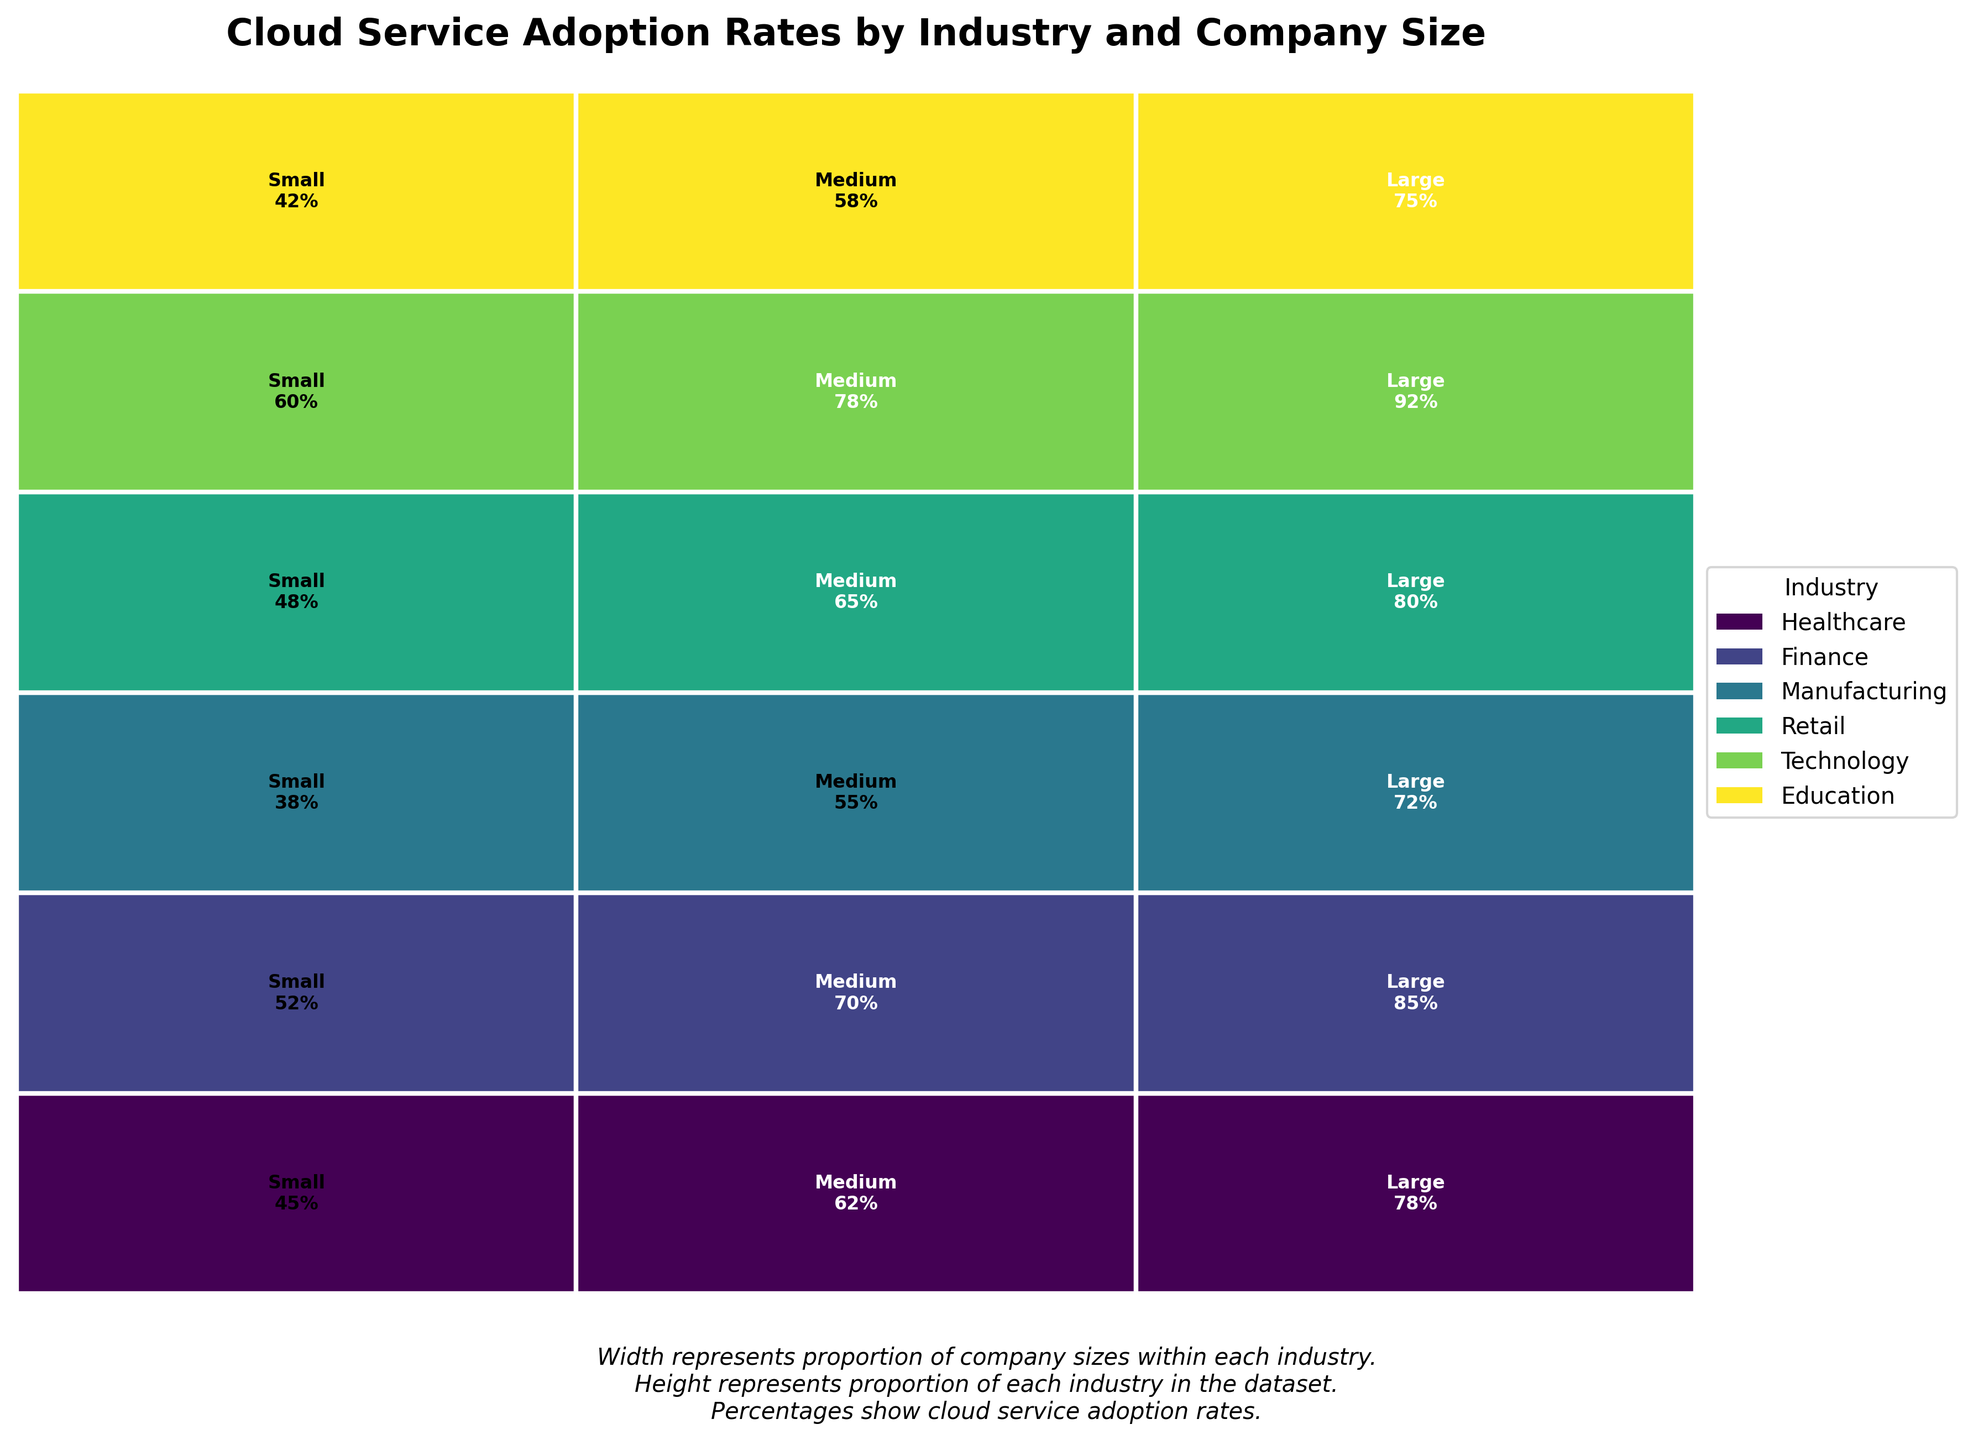Which industry has the highest cloud service adoption rate for large companies? In the mosaic plot, look for the industry with the highest adoption rate percentage for large companies. Technology shows the highest percentage for large companies at 92%.
Answer: Technology Which company size within the healthcare industry has the lowest cloud service adoption rate? Find the adoption rates for all company sizes within the healthcare industry. The small businesses in healthcare have the lowest adoption rate at 45%.
Answer: Small Compare the cloud service adoption rates between medium-sized companies in the finance and retail industries. Which one is higher, and by how much? Refer to the adoption rates for medium-sized companies in both industries. Finance has a rate of 70%, and Retail has 65%. The difference is 70% - 65% = 5%.
Answer: Finance; 5% Which industry has the lowest cloud service adoption rate for medium-sized companies? Identify the adoption rates for medium-sized companies across all industries. Manufacturing has the lowest adoption rate at 55%.
Answer: Manufacturing What is the total sum of cloud service adoption rates for the technology industry across all company sizes? Sum up the adoption rates for small, medium, and large companies in the technology industry: 60% + 78% + 92% = 230%.
Answer: 230% Is there any industry where the adoption rate increases consistently with the company size? Check whether adoption rates increase from small to medium to large companies within any industry. All industries exhibit this pattern.
Answer: Yes In the retail industry, what is the difference in cloud service adoption rates between small and large companies? Find the adoption rates for small and large companies in retail and calculate the difference: 80% - 48% = 32%.
Answer: 32% Which industry shows the least variation in cloud service adoption rates across company sizes? Calculate the difference between the highest and lowest adoption rates in each industry. Education shows the least variation with rates of 42%, 58%, and 75%, where 75% - 42% = 33%.
Answer: Education 